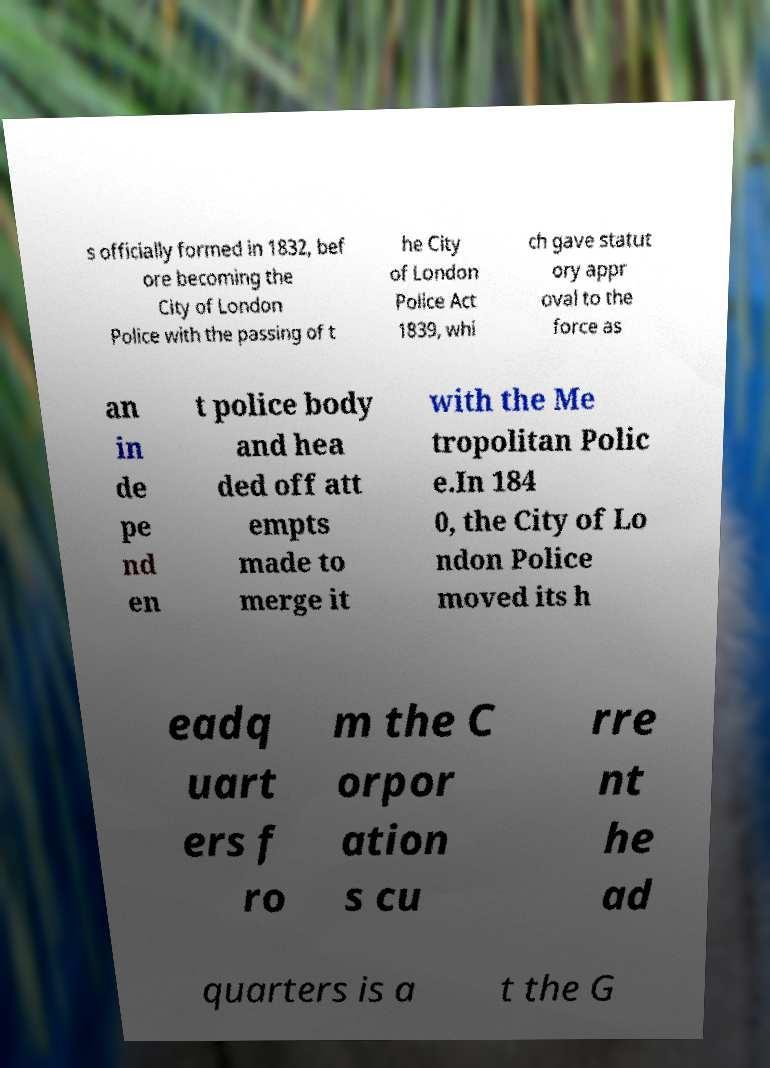Could you assist in decoding the text presented in this image and type it out clearly? s officially formed in 1832, bef ore becoming the City of London Police with the passing of t he City of London Police Act 1839, whi ch gave statut ory appr oval to the force as an in de pe nd en t police body and hea ded off att empts made to merge it with the Me tropolitan Polic e.In 184 0, the City of Lo ndon Police moved its h eadq uart ers f ro m the C orpor ation s cu rre nt he ad quarters is a t the G 